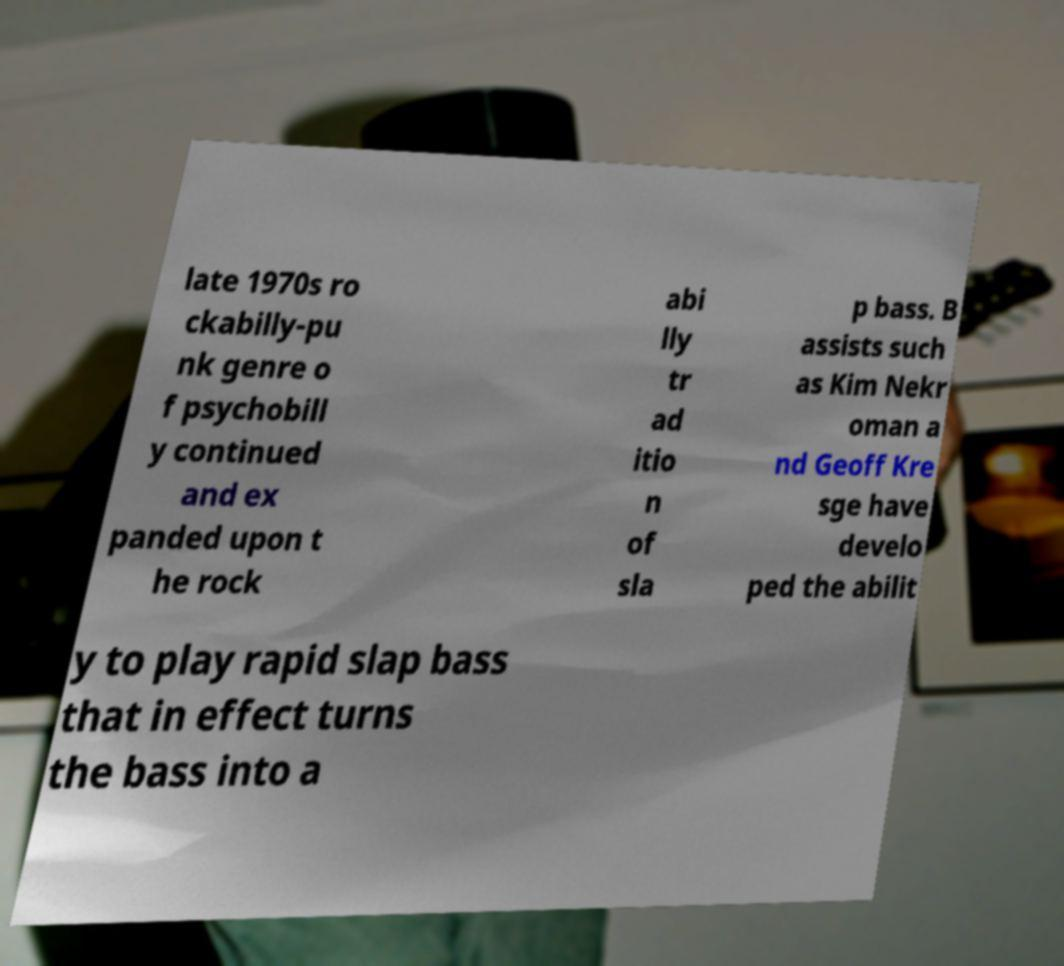I need the written content from this picture converted into text. Can you do that? late 1970s ro ckabilly-pu nk genre o f psychobill y continued and ex panded upon t he rock abi lly tr ad itio n of sla p bass. B assists such as Kim Nekr oman a nd Geoff Kre sge have develo ped the abilit y to play rapid slap bass that in effect turns the bass into a 